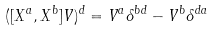Convert formula to latex. <formula><loc_0><loc_0><loc_500><loc_500>( [ X ^ { a } , X ^ { b } ] V ) ^ { d } = V ^ { a } \delta ^ { b d } - V ^ { b } \delta ^ { d a }</formula> 